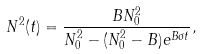Convert formula to latex. <formula><loc_0><loc_0><loc_500><loc_500>N ^ { 2 } ( t ) = \frac { B N _ { 0 } ^ { 2 } } { N _ { 0 } ^ { 2 } - ( N _ { 0 } ^ { 2 } - B ) e ^ { B \sigma t } } ,</formula> 